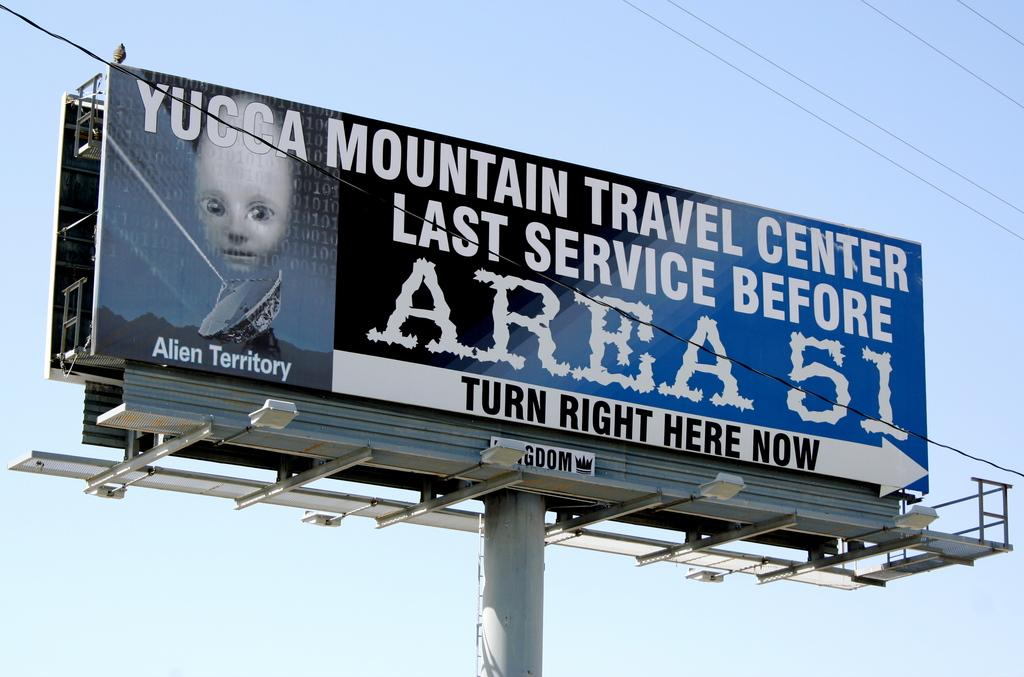Provide a one-sentence caption for the provided image. A billboard sign advertising Mountain Travel Center as the last service before area 51. 